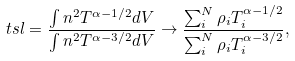<formula> <loc_0><loc_0><loc_500><loc_500>\ t s l = \frac { \int n ^ { 2 } T ^ { \alpha - 1 / 2 } d V } { \int n ^ { 2 } T ^ { \alpha - 3 / 2 } d V } \rightarrow \frac { \sum _ { i } ^ { N } \rho _ { i } T _ { i } ^ { \alpha - 1 / 2 } } { \sum _ { i } ^ { N } \rho _ { i } T _ { i } ^ { \alpha - 3 / 2 } } ,</formula> 